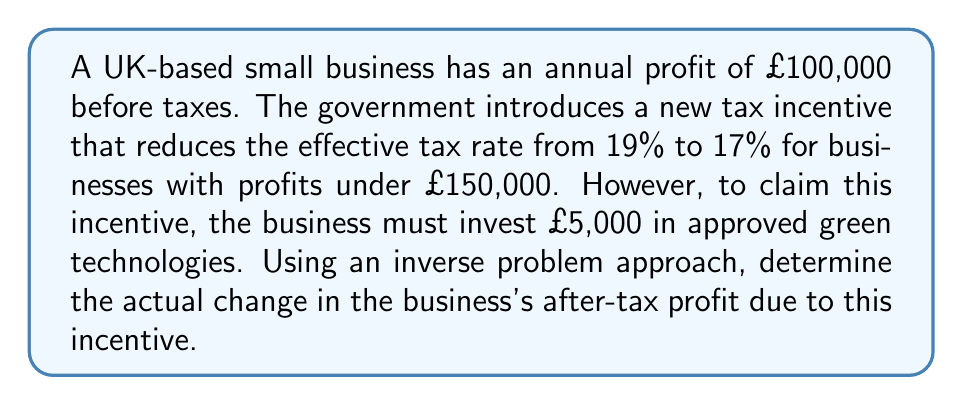Teach me how to tackle this problem. Let's approach this step-by-step using an inverse problem method:

1) First, let's calculate the profit without the incentive:
   Pre-tax profit: £100,000
   Tax at 19%: $100,000 \times 0.19 = £19,000$
   After-tax profit: $100,000 - 19,000 = £81,000$

2) Now, let's calculate the profit with the incentive:
   Pre-tax profit: £100,000
   Investment in green technologies: £5,000
   Adjusted pre-tax profit: $100,000 - 5,000 = £95,000$
   Tax at 17%: $95,000 \times 0.17 = £16,150$
   After-tax profit: $95,000 - 16,150 = £78,850$

3) To solve the inverse problem, we need to find the difference:
   Change in after-tax profit: $78,850 - 81,000 = -£2,150$

4) This negative value indicates that despite the lower tax rate, the business actually loses money due to the required investment.

5) To verify this result, we can calculate the break-even point for the investment:
   Let $x$ be the pre-tax profit where the old and new scenarios are equal:
   $x - 0.19x = (x - 5000) - 0.17(x - 5000)$
   $0.81x = 0.83x - 4150$
   $4150 = 0.02x$
   $x = 207,500$

This means that for any profit below £207,500, the business would be worse off with the incentive, confirming our result.
Answer: £-2,150 